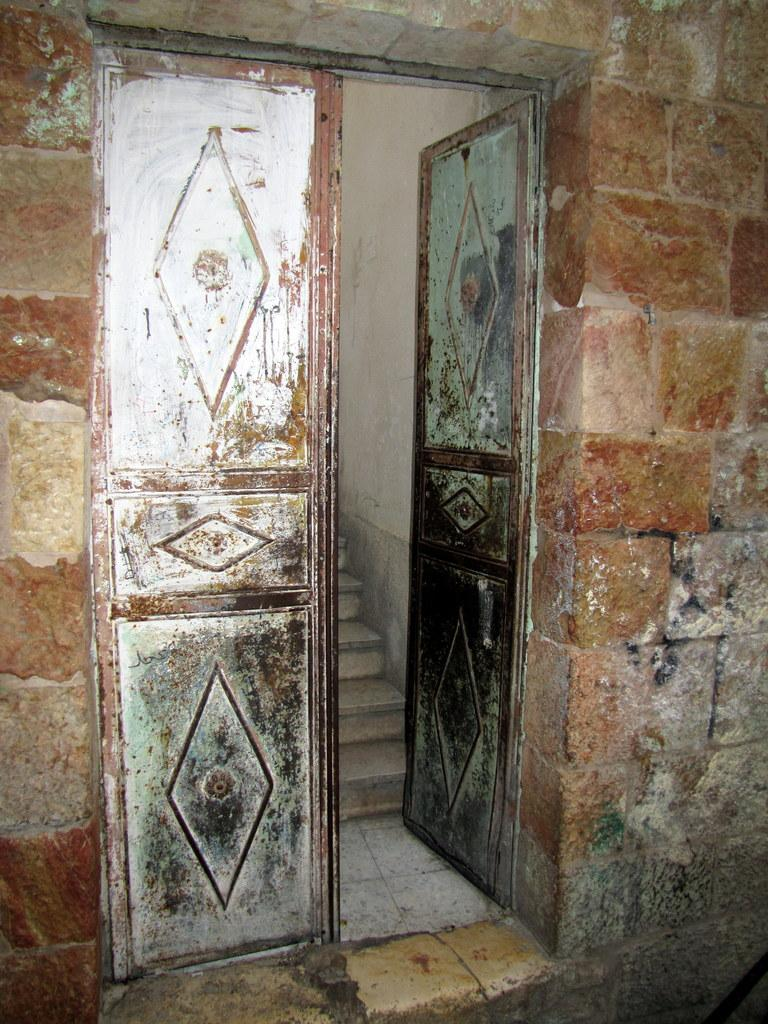What type of door is shown in the image? There is a steel door in the image. Where is the steel door located? The steel door is on a wall. What can be seen near the door in the image? Stars are visible near the door. What type of operation is being performed on the door in the image? There is no operation being performed on the door in the image; it is simply a steel door on a wall. 